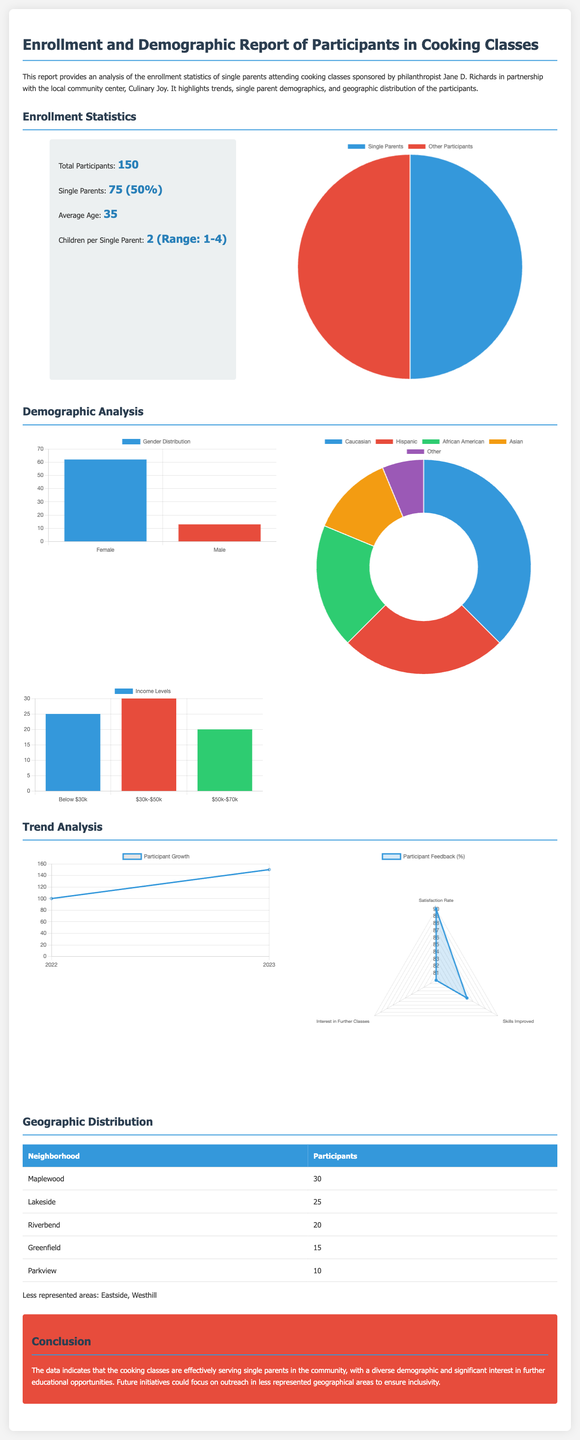What is the total number of participants? The document states that there are a total of 150 participants in the cooking classes.
Answer: 150 How many single parents are enrolled? According to the report, 75 participants are single parents, which constitutes 50% of the total enrollment.
Answer: 75 (50%) What is the average age of participants? The report indicates that the average age of all participants is 35 years.
Answer: 35 What is the range of children per single parent? The document notes that the number of children per single parent ranges from 1 to 4.
Answer: 1-4 Which neighborhood has the highest number of participants? The report lists Maplewood as having the highest number of participants, totaling 30.
Answer: Maplewood What percentage of single parents are female? The report shows that 62 out of 75 single parents are female, implying approximately 82.67% are female.
Answer: 82.67% What was the participant growth from 2022 to 2023? The document highlights that the participant count grew from 100 in 2022 to 150 in 2023.
Answer: 50 What is the satisfaction rate reported by participants? The document indicates a satisfaction rate of 90% among participants.
Answer: 90% Which income bracket has the most participants? The report shows that the income bracket of $30k-$50k has the highest number of participants, totaling 30.
Answer: $30k-$50k 